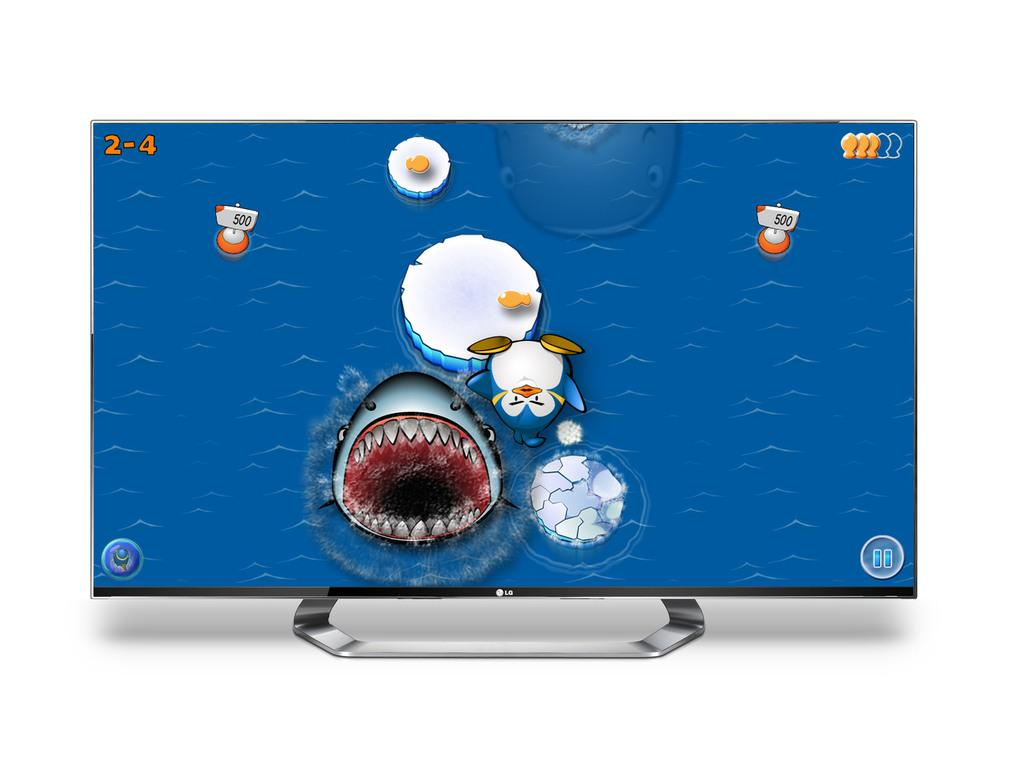<image>
Relay a brief, clear account of the picture shown. a pictur eof a shark is on a screen which has 2-4 on orange in the top left. 